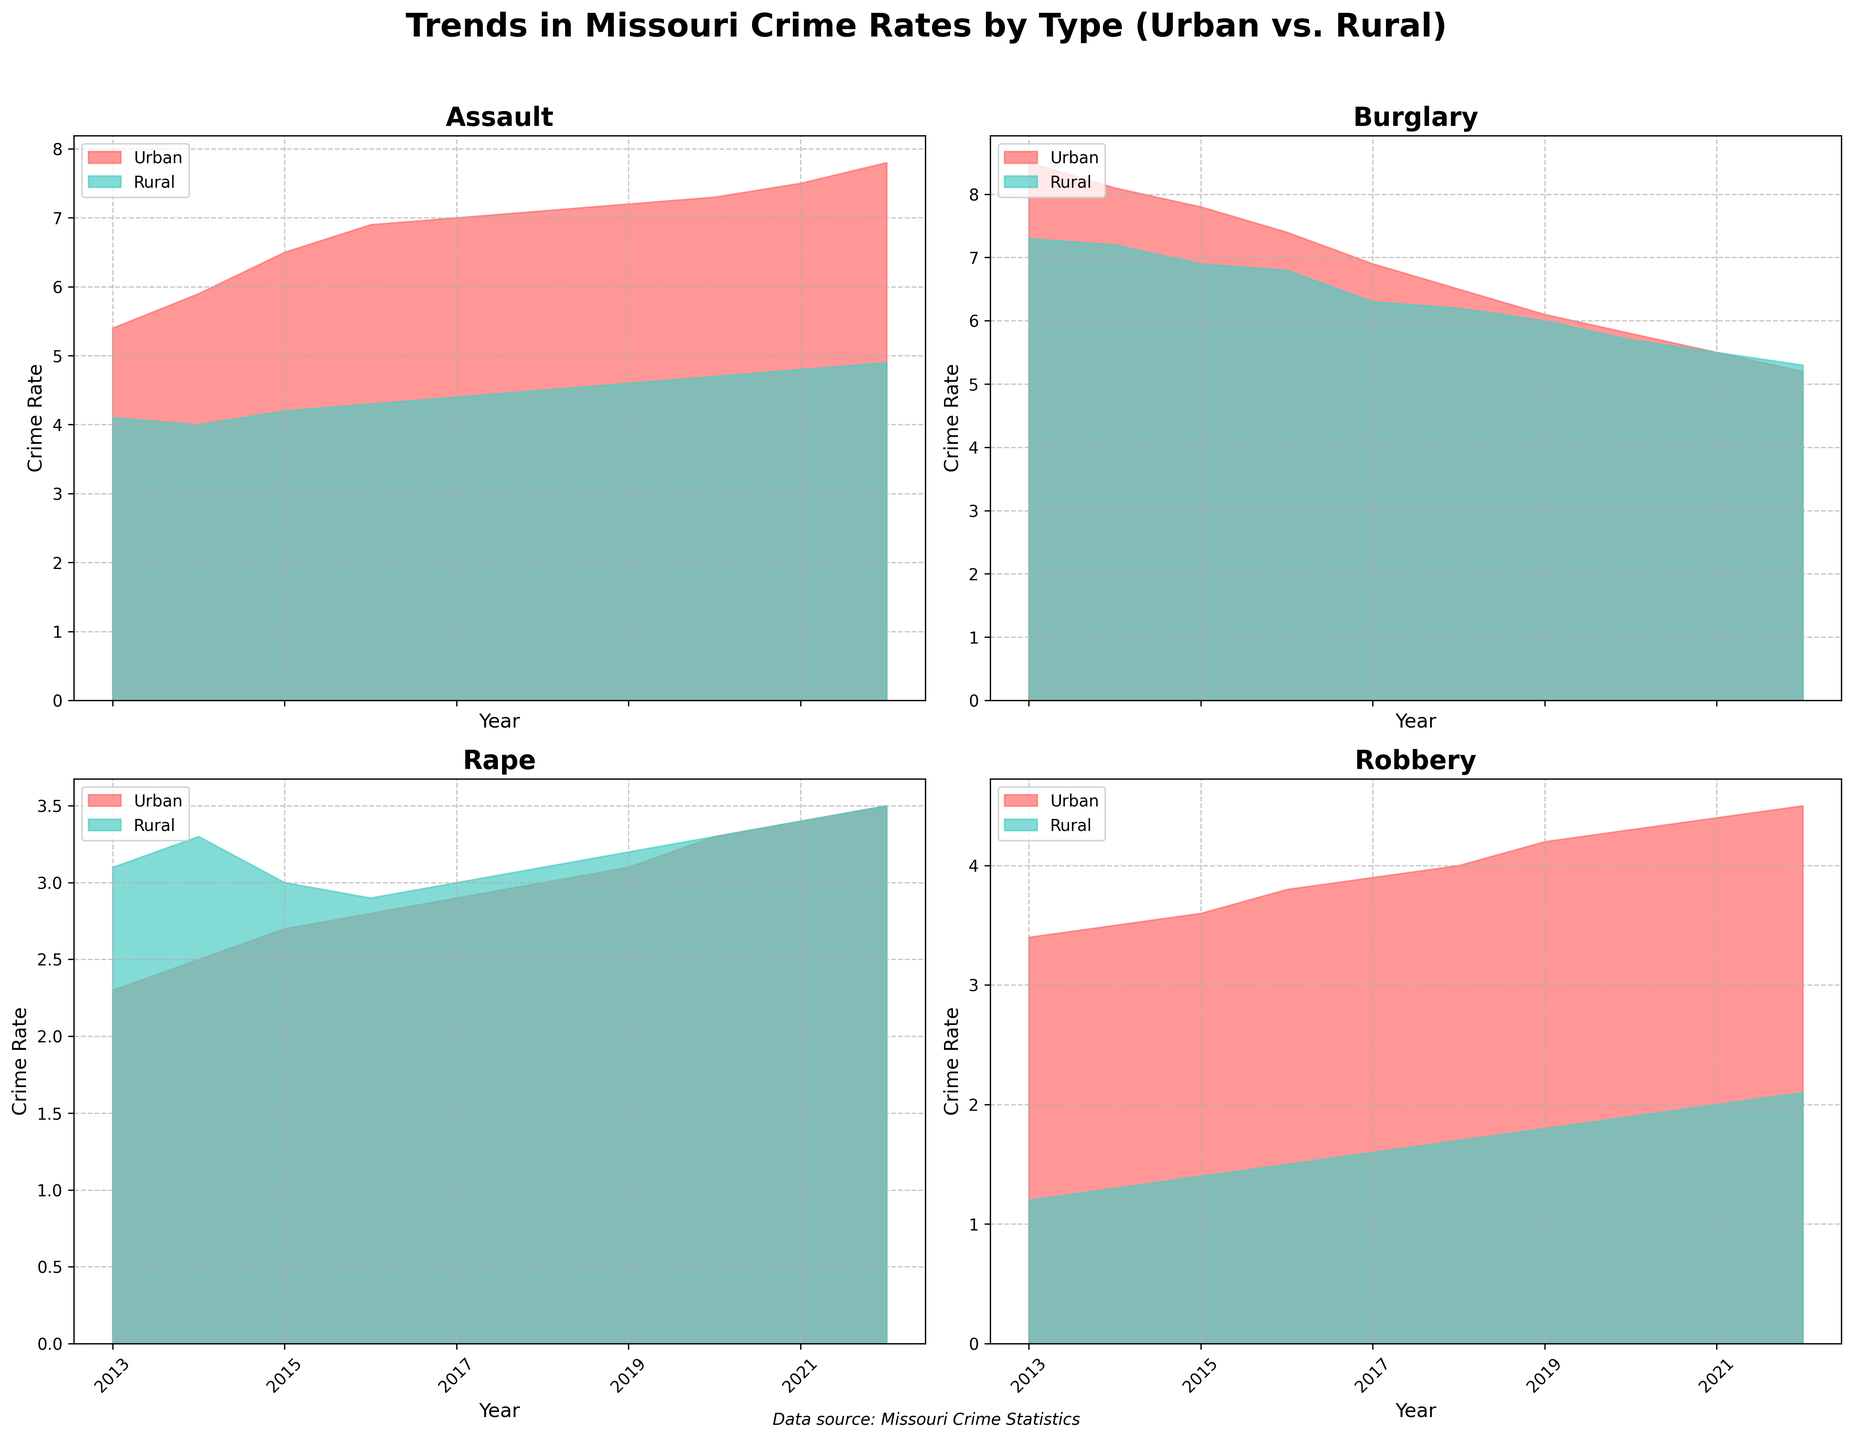What is the title of the figure? The title is found at the top of the figure. It is "Trends in Missouri Crime Rates by Type (Urban vs. Rural)."
Answer: Trends in Missouri Crime Rates by Type (Urban vs. Rural) How many types of crimes are represented in the figure? Each type of crime has its own subplot. By counting the subplots, we can determine there are four types of crimes represented.
Answer: 4 Which type of crime had the highest urban crime rate in 2022? Look at the urban data in 2022 across all subplots. The highest crime rate is found under "Assault" with a rate of 7.8.
Answer: Assault Did the rural robbery crime rate increase or decrease from 2013 to 2022? Compare the rural robbery crime rate in 2013 and 2022. It increased from 1.2 to 2.1.
Answer: Increase Which region had a higher rate of burglary in 2018, urban or rural? Compare the urban and rural rates for burglary in 2018. Urban had a rate of 6.5 while rural had a rate of 6.2. Thus, urban had a higher rate.
Answer: Urban By how much did the rate of urban assault increase from 2013 to 2022? Subtract the 2013 rate of urban assault (5.4) from the 2022 rate (7.8). The increase is 7.8 - 5.4 = 2.4.
Answer: 2.4 What is the average crime rate for rural rape from 2013 to 2022? Add all the rural rape rates from 2013 to 2022 and divide by the number of years (10). Calculation: (3.1 + 3.3 + 3.0 + 2.9 + 3.0 + 3.1 + 3.2 + 3.3 + 3.4 + 3.5) / 10 = 3.08.
Answer: 3.08 In which year did urban burglary experience the largest drop in rate? Examine the urban burglary rates and identify the year with the largest difference between consecutive years. The largest drop was from 2013 (8.5) to 2014 (8.1), a decrease of 0.4.
Answer: 2013 to 2014 Which type of crime in rural areas showed the least variation over the decade? Check the range (difference between the maximum and minimum values) for each crime type in rural areas. "Assault" has the least variation with a range of 4.1 to 4.9 (0.8).
Answer: Assault What is the overall trend in urban rape rates from 2013 to 2022? Observe the urban rape rates from 2013 (2.3) to 2022 (3.5). The rates generally increase over the decade.
Answer: Increasing 